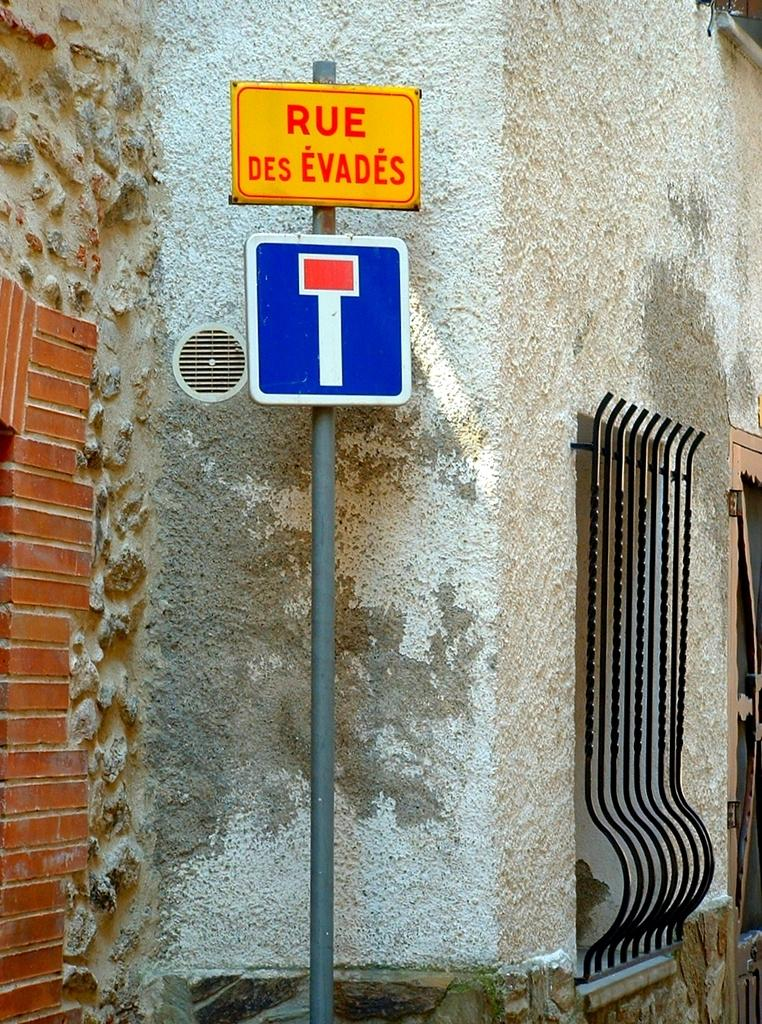Provide a one-sentence caption for the provided image. A sign that says, 'Rue Des Evades', is on a pole next to a wall. 